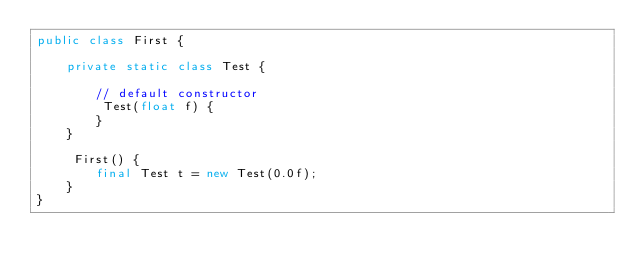<code> <loc_0><loc_0><loc_500><loc_500><_Java_>public class First {

    private static class Test {

        // default constructor
         Test(float f) {
        }
    }

     First() {
        final Test t = new Test(0.0f);
    }
}
</code> 